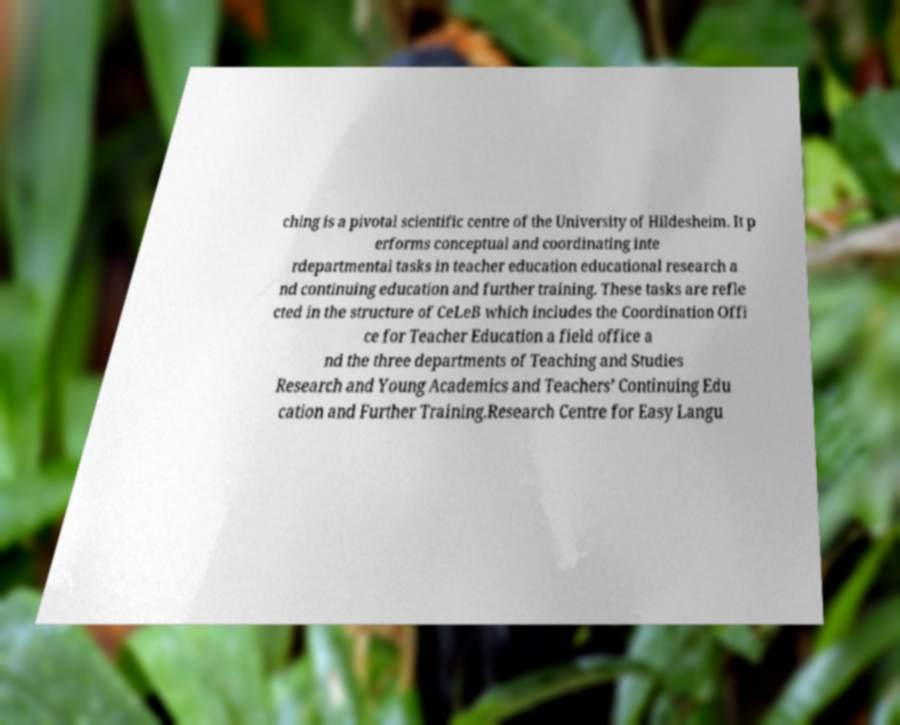Can you accurately transcribe the text from the provided image for me? ching is a pivotal scientific centre of the University of Hildesheim. It p erforms conceptual and coordinating inte rdepartmental tasks in teacher education educational research a nd continuing education and further training. These tasks are refle cted in the structure of CeLeB which includes the Coordination Offi ce for Teacher Education a field office a nd the three departments of Teaching and Studies Research and Young Academics and Teachers’ Continuing Edu cation and Further Training.Research Centre for Easy Langu 